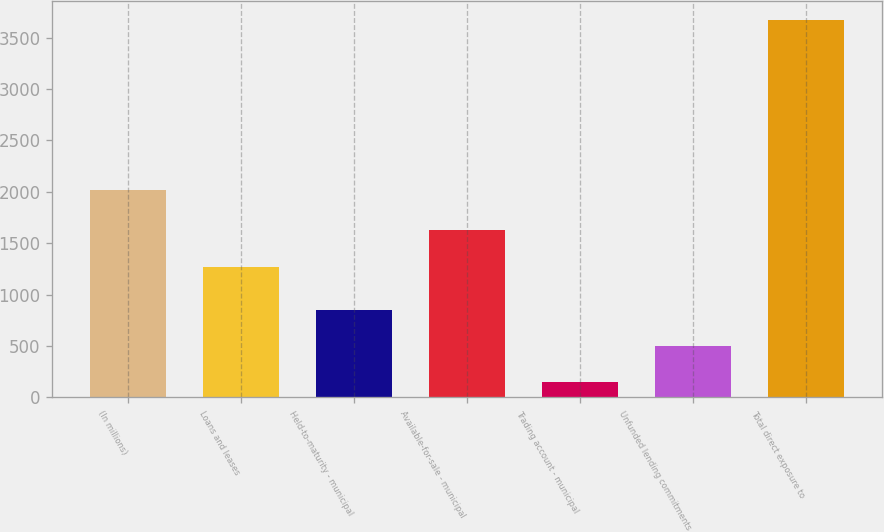<chart> <loc_0><loc_0><loc_500><loc_500><bar_chart><fcel>(In millions)<fcel>Loans and leases<fcel>Held-to-maturity - municipal<fcel>Available-for-sale - municipal<fcel>Trading account - municipal<fcel>Unfunded lending commitments<fcel>Total direct exposure to<nl><fcel>2017<fcel>1271<fcel>851.4<fcel>1623.7<fcel>146<fcel>498.7<fcel>3673<nl></chart> 